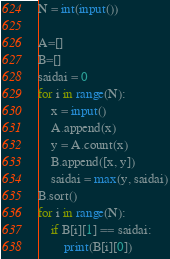<code> <loc_0><loc_0><loc_500><loc_500><_Python_>N = int(input())

A=[]
B=[]
saidai = 0
for i in range(N):
    x = input()
    A.append(x)
    y = A.count(x)
    B.append([x, y])
    saidai = max(y, saidai)
B.sort() 
for i in range(N):
    if B[i][1] == saidai:
        print(B[i][0])</code> 